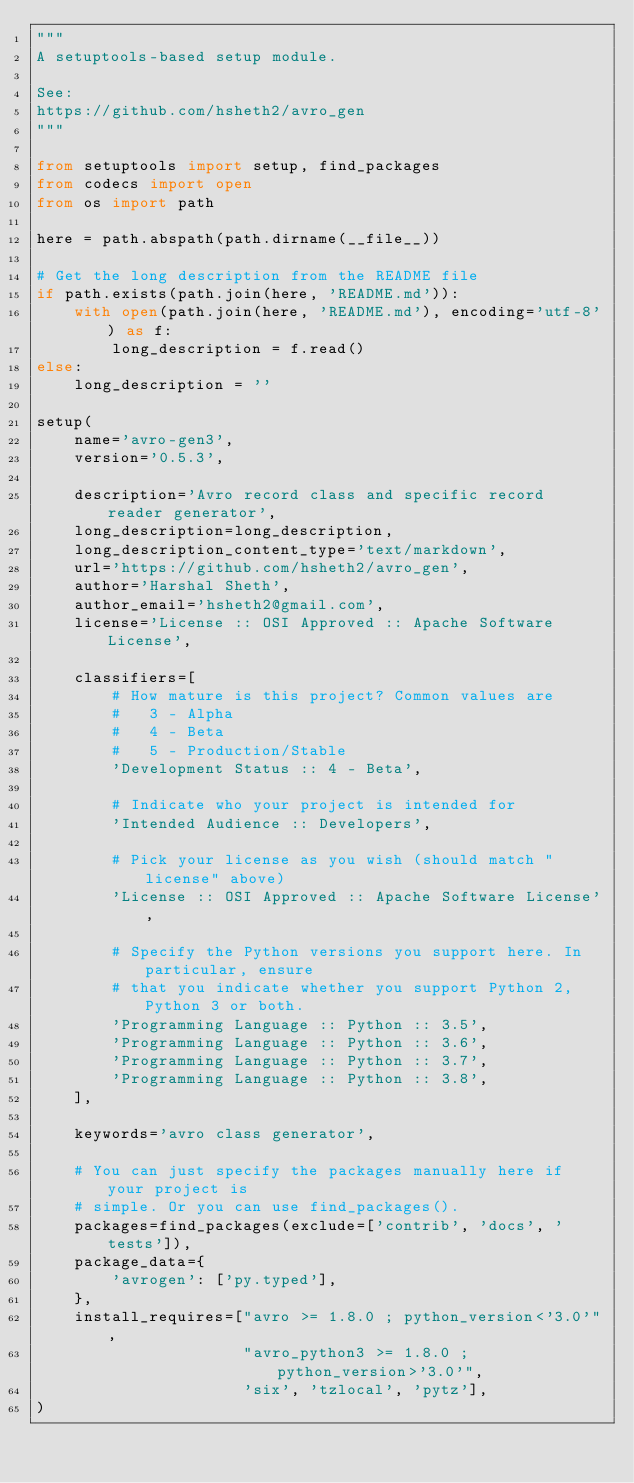<code> <loc_0><loc_0><loc_500><loc_500><_Python_>"""
A setuptools-based setup module.

See:
https://github.com/hsheth2/avro_gen
"""

from setuptools import setup, find_packages
from codecs import open
from os import path

here = path.abspath(path.dirname(__file__))

# Get the long description from the README file
if path.exists(path.join(here, 'README.md')):
    with open(path.join(here, 'README.md'), encoding='utf-8') as f:
        long_description = f.read()
else:
    long_description = ''

setup(
    name='avro-gen3',
    version='0.5.3',

    description='Avro record class and specific record reader generator',
    long_description=long_description,
    long_description_content_type='text/markdown',
    url='https://github.com/hsheth2/avro_gen',
    author='Harshal Sheth',
    author_email='hsheth2@gmail.com',
    license='License :: OSI Approved :: Apache Software License',

    classifiers=[
        # How mature is this project? Common values are
        #   3 - Alpha
        #   4 - Beta
        #   5 - Production/Stable
        'Development Status :: 4 - Beta',

        # Indicate who your project is intended for
        'Intended Audience :: Developers',

        # Pick your license as you wish (should match "license" above)
        'License :: OSI Approved :: Apache Software License',

        # Specify the Python versions you support here. In particular, ensure
        # that you indicate whether you support Python 2, Python 3 or both.
        'Programming Language :: Python :: 3.5',
        'Programming Language :: Python :: 3.6',
        'Programming Language :: Python :: 3.7',
        'Programming Language :: Python :: 3.8',
    ],

    keywords='avro class generator',

    # You can just specify the packages manually here if your project is
    # simple. Or you can use find_packages().
    packages=find_packages(exclude=['contrib', 'docs', 'tests']),
    package_data={
        'avrogen': ['py.typed'],
    },
    install_requires=["avro >= 1.8.0 ; python_version<'3.0'",
                      "avro_python3 >= 1.8.0 ; python_version>'3.0'",
                      'six', 'tzlocal', 'pytz'],
)
</code> 